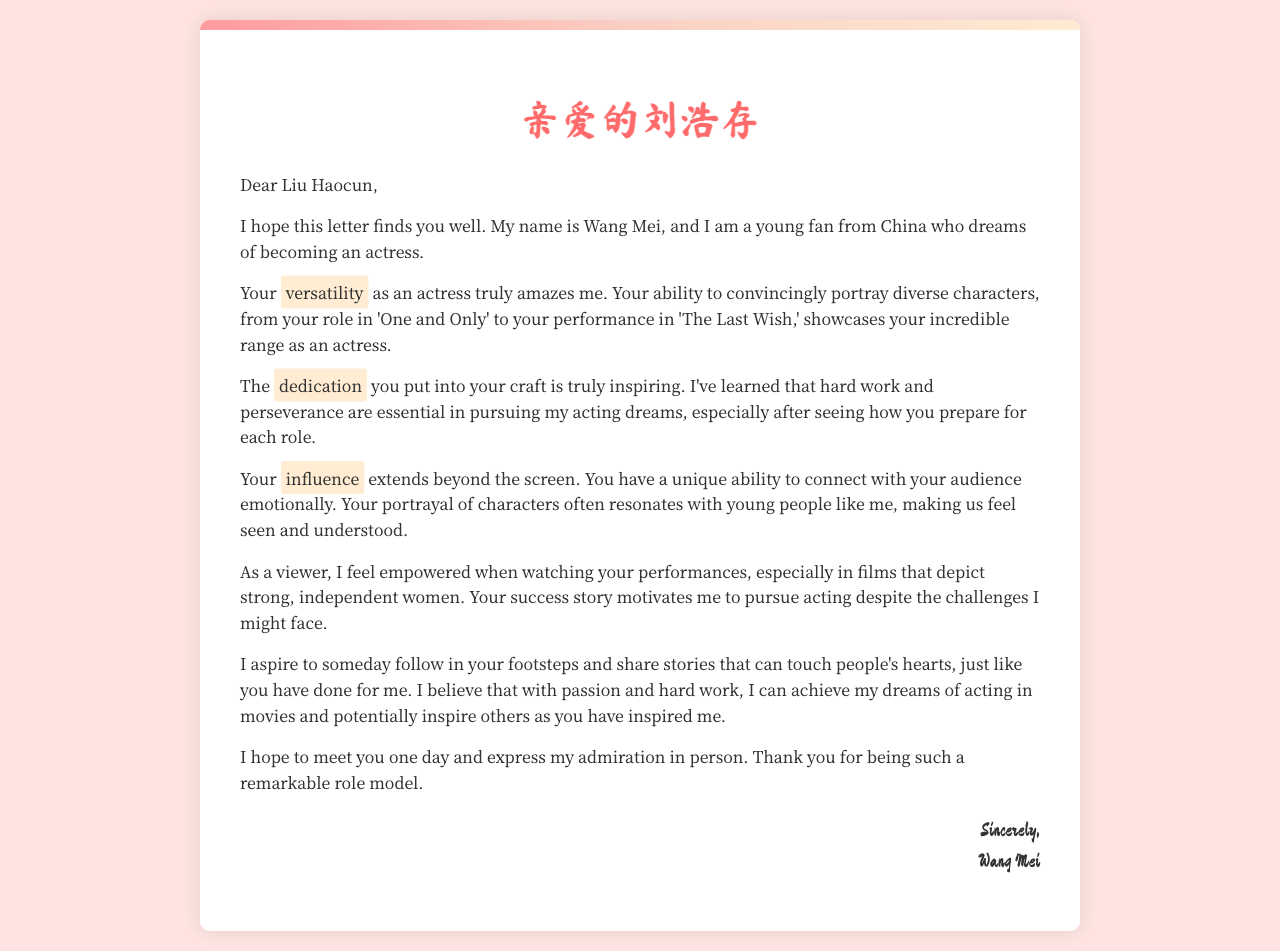What is the name of the sender? The sender's name is mentioned at the end of the letter.
Answer: Wang Mei What is the purpose of the letter? The purpose is to express admiration for Liu Haocun and share aspirations of becoming an actress.
Answer: To express admiration Which films are mentioned in the letter? The films referenced showcase Liu Haocun's versatility as an actress.
Answer: One and Only, The Last Wish What quality does the sender admire in Liu Haocun? The sender admires Liu Haocun's ability to connect emotionally with her audience.
Answer: Connection with audience What is the sender's dream? The sender shares her aspiration to pursue a career in acting.
Answer: To become an actress How does the sender feel about Liu Haocun's impact? The sender feels empowered by Liu Haocun's performances.
Answer: Empowered What does the sender aspire to do in the future? The sender expresses a desire to share stories that touch people's hearts.
Answer: Share touching stories What kind of women does the sender admire in film? The sender mentions a preference for films that depict strong, independent women.
Answer: Strong, independent women 